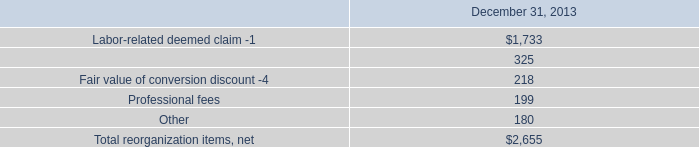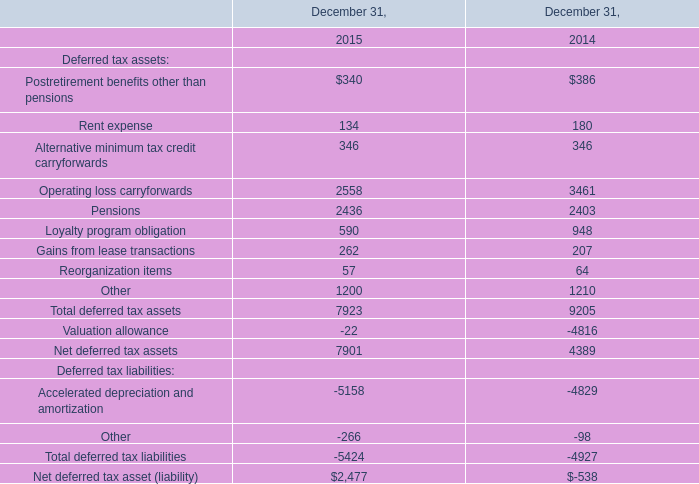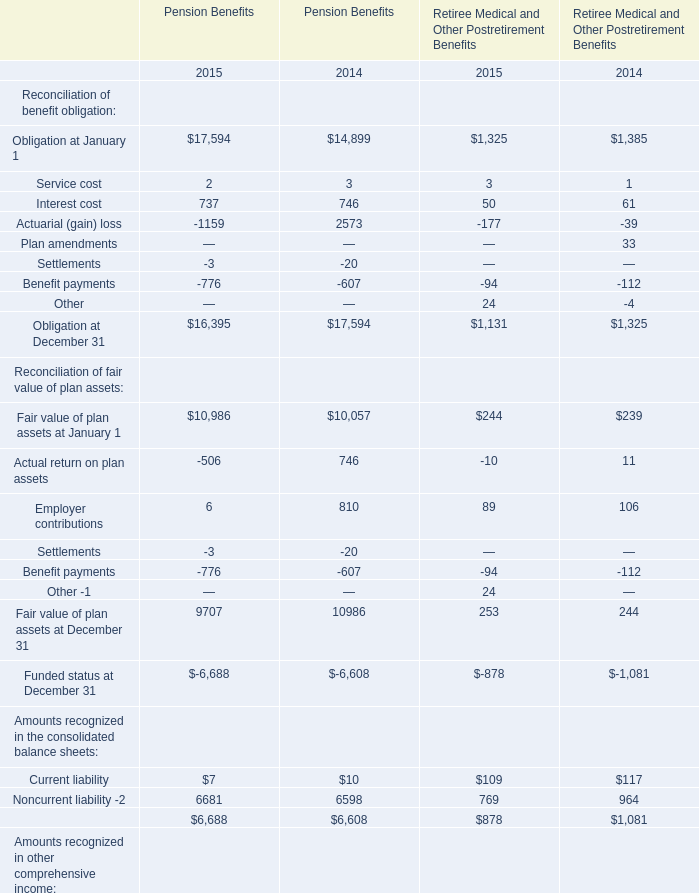What's the sum of Obligation at December 31 of Pension Benefits 2015, and Other of December 31, 2014 ? 
Computations: (16395.0 + 1210.0)
Answer: 17605.0. 